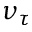<formula> <loc_0><loc_0><loc_500><loc_500>\nu _ { \tau }</formula> 